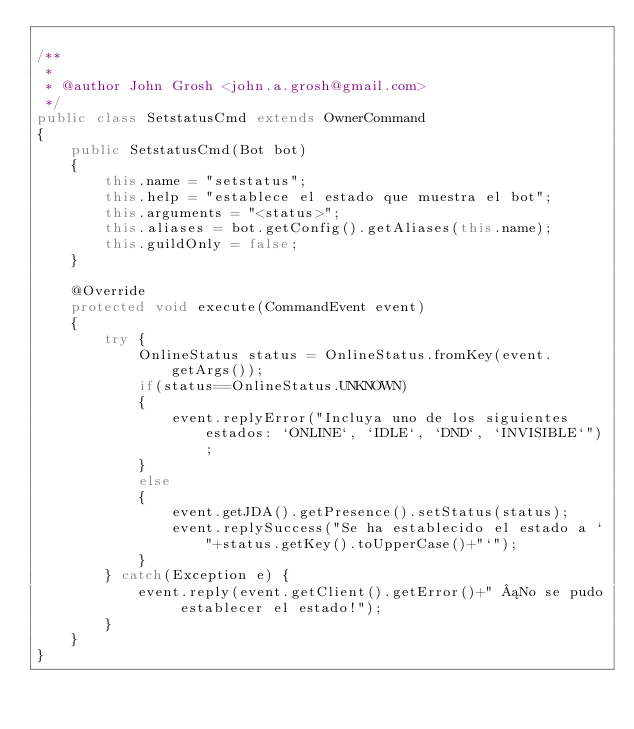<code> <loc_0><loc_0><loc_500><loc_500><_Java_>
/**
 *
 * @author John Grosh <john.a.grosh@gmail.com>
 */
public class SetstatusCmd extends OwnerCommand
{
    public SetstatusCmd(Bot bot)
    {
        this.name = "setstatus";
        this.help = "establece el estado que muestra el bot";
        this.arguments = "<status>";
        this.aliases = bot.getConfig().getAliases(this.name);
        this.guildOnly = false;
    }
    
    @Override
    protected void execute(CommandEvent event) 
    {
        try {
            OnlineStatus status = OnlineStatus.fromKey(event.getArgs());
            if(status==OnlineStatus.UNKNOWN)
            {
                event.replyError("Incluya uno de los siguientes estados: `ONLINE`, `IDLE`, `DND`, `INVISIBLE`");
            }
            else
            {
                event.getJDA().getPresence().setStatus(status);
                event.replySuccess("Se ha establecido el estado a `"+status.getKey().toUpperCase()+"`");
            }
        } catch(Exception e) {
            event.reply(event.getClient().getError()+" ¡No se pudo establecer el estado!");
        }
    }
}
</code> 